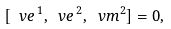<formula> <loc_0><loc_0><loc_500><loc_500>[ \ v e ^ { \, 1 } , \ v e ^ { \, 2 } , \ v m ^ { 2 } ] = 0 ,</formula> 